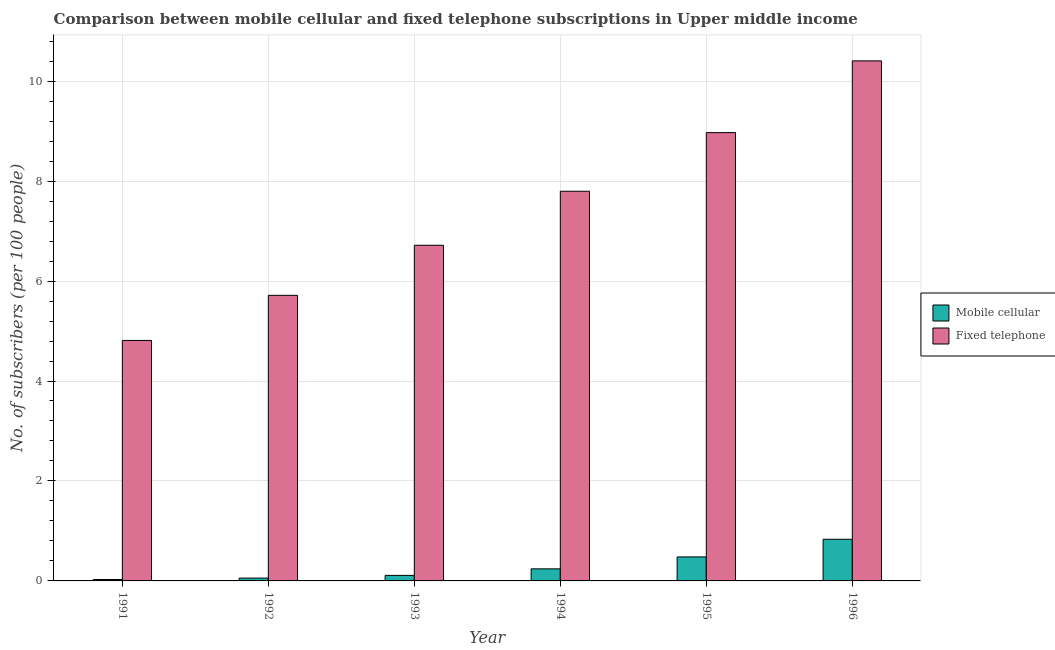How many groups of bars are there?
Your response must be concise. 6. Are the number of bars per tick equal to the number of legend labels?
Offer a terse response. Yes. How many bars are there on the 4th tick from the right?
Your answer should be compact. 2. What is the label of the 5th group of bars from the left?
Give a very brief answer. 1995. In how many cases, is the number of bars for a given year not equal to the number of legend labels?
Offer a terse response. 0. What is the number of mobile cellular subscribers in 1995?
Offer a very short reply. 0.48. Across all years, what is the maximum number of mobile cellular subscribers?
Ensure brevity in your answer.  0.83. Across all years, what is the minimum number of fixed telephone subscribers?
Provide a short and direct response. 4.81. What is the total number of fixed telephone subscribers in the graph?
Offer a terse response. 44.41. What is the difference between the number of mobile cellular subscribers in 1993 and that in 1996?
Ensure brevity in your answer.  -0.72. What is the difference between the number of mobile cellular subscribers in 1992 and the number of fixed telephone subscribers in 1995?
Offer a terse response. -0.42. What is the average number of fixed telephone subscribers per year?
Offer a very short reply. 7.4. What is the ratio of the number of fixed telephone subscribers in 1992 to that in 1993?
Make the answer very short. 0.85. Is the number of fixed telephone subscribers in 1993 less than that in 1994?
Provide a succinct answer. Yes. What is the difference between the highest and the second highest number of fixed telephone subscribers?
Your answer should be compact. 1.44. What is the difference between the highest and the lowest number of fixed telephone subscribers?
Give a very brief answer. 5.59. Is the sum of the number of fixed telephone subscribers in 1994 and 1996 greater than the maximum number of mobile cellular subscribers across all years?
Offer a terse response. Yes. What does the 1st bar from the left in 1993 represents?
Your response must be concise. Mobile cellular. What does the 2nd bar from the right in 1995 represents?
Ensure brevity in your answer.  Mobile cellular. How many bars are there?
Provide a short and direct response. 12. Are all the bars in the graph horizontal?
Provide a succinct answer. No. How many years are there in the graph?
Make the answer very short. 6. Does the graph contain grids?
Your response must be concise. Yes. What is the title of the graph?
Provide a short and direct response. Comparison between mobile cellular and fixed telephone subscriptions in Upper middle income. Does "Electricity and heat production" appear as one of the legend labels in the graph?
Keep it short and to the point. No. What is the label or title of the X-axis?
Offer a terse response. Year. What is the label or title of the Y-axis?
Keep it short and to the point. No. of subscribers (per 100 people). What is the No. of subscribers (per 100 people) in Mobile cellular in 1991?
Make the answer very short. 0.03. What is the No. of subscribers (per 100 people) of Fixed telephone in 1991?
Ensure brevity in your answer.  4.81. What is the No. of subscribers (per 100 people) of Mobile cellular in 1992?
Your answer should be very brief. 0.06. What is the No. of subscribers (per 100 people) of Fixed telephone in 1992?
Ensure brevity in your answer.  5.71. What is the No. of subscribers (per 100 people) of Mobile cellular in 1993?
Your response must be concise. 0.11. What is the No. of subscribers (per 100 people) in Fixed telephone in 1993?
Offer a terse response. 6.72. What is the No. of subscribers (per 100 people) in Mobile cellular in 1994?
Ensure brevity in your answer.  0.24. What is the No. of subscribers (per 100 people) of Fixed telephone in 1994?
Your answer should be very brief. 7.8. What is the No. of subscribers (per 100 people) of Mobile cellular in 1995?
Offer a very short reply. 0.48. What is the No. of subscribers (per 100 people) in Fixed telephone in 1995?
Offer a terse response. 8.97. What is the No. of subscribers (per 100 people) in Mobile cellular in 1996?
Offer a terse response. 0.83. What is the No. of subscribers (per 100 people) of Fixed telephone in 1996?
Your response must be concise. 10.41. Across all years, what is the maximum No. of subscribers (per 100 people) of Mobile cellular?
Offer a very short reply. 0.83. Across all years, what is the maximum No. of subscribers (per 100 people) in Fixed telephone?
Give a very brief answer. 10.41. Across all years, what is the minimum No. of subscribers (per 100 people) of Mobile cellular?
Make the answer very short. 0.03. Across all years, what is the minimum No. of subscribers (per 100 people) in Fixed telephone?
Offer a terse response. 4.81. What is the total No. of subscribers (per 100 people) of Mobile cellular in the graph?
Provide a short and direct response. 1.75. What is the total No. of subscribers (per 100 people) of Fixed telephone in the graph?
Provide a succinct answer. 44.41. What is the difference between the No. of subscribers (per 100 people) in Mobile cellular in 1991 and that in 1992?
Give a very brief answer. -0.03. What is the difference between the No. of subscribers (per 100 people) of Fixed telephone in 1991 and that in 1992?
Keep it short and to the point. -0.9. What is the difference between the No. of subscribers (per 100 people) in Mobile cellular in 1991 and that in 1993?
Provide a short and direct response. -0.08. What is the difference between the No. of subscribers (per 100 people) of Fixed telephone in 1991 and that in 1993?
Offer a terse response. -1.9. What is the difference between the No. of subscribers (per 100 people) in Mobile cellular in 1991 and that in 1994?
Make the answer very short. -0.21. What is the difference between the No. of subscribers (per 100 people) in Fixed telephone in 1991 and that in 1994?
Provide a succinct answer. -2.99. What is the difference between the No. of subscribers (per 100 people) of Mobile cellular in 1991 and that in 1995?
Ensure brevity in your answer.  -0.45. What is the difference between the No. of subscribers (per 100 people) in Fixed telephone in 1991 and that in 1995?
Provide a short and direct response. -4.16. What is the difference between the No. of subscribers (per 100 people) of Mobile cellular in 1991 and that in 1996?
Provide a succinct answer. -0.81. What is the difference between the No. of subscribers (per 100 people) of Fixed telephone in 1991 and that in 1996?
Your answer should be very brief. -5.59. What is the difference between the No. of subscribers (per 100 people) in Mobile cellular in 1992 and that in 1993?
Your response must be concise. -0.05. What is the difference between the No. of subscribers (per 100 people) of Fixed telephone in 1992 and that in 1993?
Make the answer very short. -1. What is the difference between the No. of subscribers (per 100 people) of Mobile cellular in 1992 and that in 1994?
Your answer should be very brief. -0.18. What is the difference between the No. of subscribers (per 100 people) in Fixed telephone in 1992 and that in 1994?
Provide a succinct answer. -2.08. What is the difference between the No. of subscribers (per 100 people) in Mobile cellular in 1992 and that in 1995?
Your answer should be compact. -0.42. What is the difference between the No. of subscribers (per 100 people) of Fixed telephone in 1992 and that in 1995?
Provide a succinct answer. -3.26. What is the difference between the No. of subscribers (per 100 people) in Mobile cellular in 1992 and that in 1996?
Offer a terse response. -0.78. What is the difference between the No. of subscribers (per 100 people) in Fixed telephone in 1992 and that in 1996?
Your response must be concise. -4.69. What is the difference between the No. of subscribers (per 100 people) in Mobile cellular in 1993 and that in 1994?
Give a very brief answer. -0.13. What is the difference between the No. of subscribers (per 100 people) of Fixed telephone in 1993 and that in 1994?
Provide a short and direct response. -1.08. What is the difference between the No. of subscribers (per 100 people) in Mobile cellular in 1993 and that in 1995?
Give a very brief answer. -0.37. What is the difference between the No. of subscribers (per 100 people) of Fixed telephone in 1993 and that in 1995?
Your answer should be compact. -2.25. What is the difference between the No. of subscribers (per 100 people) in Mobile cellular in 1993 and that in 1996?
Your answer should be very brief. -0.72. What is the difference between the No. of subscribers (per 100 people) in Fixed telephone in 1993 and that in 1996?
Give a very brief answer. -3.69. What is the difference between the No. of subscribers (per 100 people) of Mobile cellular in 1994 and that in 1995?
Offer a terse response. -0.24. What is the difference between the No. of subscribers (per 100 people) in Fixed telephone in 1994 and that in 1995?
Offer a terse response. -1.17. What is the difference between the No. of subscribers (per 100 people) in Mobile cellular in 1994 and that in 1996?
Provide a succinct answer. -0.59. What is the difference between the No. of subscribers (per 100 people) in Fixed telephone in 1994 and that in 1996?
Offer a terse response. -2.61. What is the difference between the No. of subscribers (per 100 people) in Mobile cellular in 1995 and that in 1996?
Provide a succinct answer. -0.35. What is the difference between the No. of subscribers (per 100 people) of Fixed telephone in 1995 and that in 1996?
Make the answer very short. -1.44. What is the difference between the No. of subscribers (per 100 people) in Mobile cellular in 1991 and the No. of subscribers (per 100 people) in Fixed telephone in 1992?
Offer a very short reply. -5.69. What is the difference between the No. of subscribers (per 100 people) of Mobile cellular in 1991 and the No. of subscribers (per 100 people) of Fixed telephone in 1993?
Your answer should be very brief. -6.69. What is the difference between the No. of subscribers (per 100 people) of Mobile cellular in 1991 and the No. of subscribers (per 100 people) of Fixed telephone in 1994?
Ensure brevity in your answer.  -7.77. What is the difference between the No. of subscribers (per 100 people) of Mobile cellular in 1991 and the No. of subscribers (per 100 people) of Fixed telephone in 1995?
Ensure brevity in your answer.  -8.94. What is the difference between the No. of subscribers (per 100 people) in Mobile cellular in 1991 and the No. of subscribers (per 100 people) in Fixed telephone in 1996?
Ensure brevity in your answer.  -10.38. What is the difference between the No. of subscribers (per 100 people) of Mobile cellular in 1992 and the No. of subscribers (per 100 people) of Fixed telephone in 1993?
Your answer should be compact. -6.66. What is the difference between the No. of subscribers (per 100 people) in Mobile cellular in 1992 and the No. of subscribers (per 100 people) in Fixed telephone in 1994?
Offer a very short reply. -7.74. What is the difference between the No. of subscribers (per 100 people) in Mobile cellular in 1992 and the No. of subscribers (per 100 people) in Fixed telephone in 1995?
Your response must be concise. -8.91. What is the difference between the No. of subscribers (per 100 people) of Mobile cellular in 1992 and the No. of subscribers (per 100 people) of Fixed telephone in 1996?
Offer a very short reply. -10.35. What is the difference between the No. of subscribers (per 100 people) of Mobile cellular in 1993 and the No. of subscribers (per 100 people) of Fixed telephone in 1994?
Offer a very short reply. -7.69. What is the difference between the No. of subscribers (per 100 people) in Mobile cellular in 1993 and the No. of subscribers (per 100 people) in Fixed telephone in 1995?
Make the answer very short. -8.86. What is the difference between the No. of subscribers (per 100 people) in Mobile cellular in 1993 and the No. of subscribers (per 100 people) in Fixed telephone in 1996?
Offer a terse response. -10.29. What is the difference between the No. of subscribers (per 100 people) in Mobile cellular in 1994 and the No. of subscribers (per 100 people) in Fixed telephone in 1995?
Ensure brevity in your answer.  -8.73. What is the difference between the No. of subscribers (per 100 people) of Mobile cellular in 1994 and the No. of subscribers (per 100 people) of Fixed telephone in 1996?
Your answer should be compact. -10.16. What is the difference between the No. of subscribers (per 100 people) in Mobile cellular in 1995 and the No. of subscribers (per 100 people) in Fixed telephone in 1996?
Make the answer very short. -9.93. What is the average No. of subscribers (per 100 people) of Mobile cellular per year?
Make the answer very short. 0.29. What is the average No. of subscribers (per 100 people) of Fixed telephone per year?
Make the answer very short. 7.4. In the year 1991, what is the difference between the No. of subscribers (per 100 people) in Mobile cellular and No. of subscribers (per 100 people) in Fixed telephone?
Offer a very short reply. -4.78. In the year 1992, what is the difference between the No. of subscribers (per 100 people) in Mobile cellular and No. of subscribers (per 100 people) in Fixed telephone?
Offer a terse response. -5.66. In the year 1993, what is the difference between the No. of subscribers (per 100 people) of Mobile cellular and No. of subscribers (per 100 people) of Fixed telephone?
Provide a succinct answer. -6.61. In the year 1994, what is the difference between the No. of subscribers (per 100 people) in Mobile cellular and No. of subscribers (per 100 people) in Fixed telephone?
Offer a very short reply. -7.56. In the year 1995, what is the difference between the No. of subscribers (per 100 people) in Mobile cellular and No. of subscribers (per 100 people) in Fixed telephone?
Keep it short and to the point. -8.49. In the year 1996, what is the difference between the No. of subscribers (per 100 people) in Mobile cellular and No. of subscribers (per 100 people) in Fixed telephone?
Ensure brevity in your answer.  -9.57. What is the ratio of the No. of subscribers (per 100 people) in Mobile cellular in 1991 to that in 1992?
Your answer should be very brief. 0.5. What is the ratio of the No. of subscribers (per 100 people) in Fixed telephone in 1991 to that in 1992?
Ensure brevity in your answer.  0.84. What is the ratio of the No. of subscribers (per 100 people) in Mobile cellular in 1991 to that in 1993?
Make the answer very short. 0.26. What is the ratio of the No. of subscribers (per 100 people) of Fixed telephone in 1991 to that in 1993?
Keep it short and to the point. 0.72. What is the ratio of the No. of subscribers (per 100 people) of Mobile cellular in 1991 to that in 1994?
Your answer should be compact. 0.12. What is the ratio of the No. of subscribers (per 100 people) of Fixed telephone in 1991 to that in 1994?
Your answer should be compact. 0.62. What is the ratio of the No. of subscribers (per 100 people) of Mobile cellular in 1991 to that in 1995?
Give a very brief answer. 0.06. What is the ratio of the No. of subscribers (per 100 people) of Fixed telephone in 1991 to that in 1995?
Keep it short and to the point. 0.54. What is the ratio of the No. of subscribers (per 100 people) of Mobile cellular in 1991 to that in 1996?
Your response must be concise. 0.03. What is the ratio of the No. of subscribers (per 100 people) in Fixed telephone in 1991 to that in 1996?
Offer a very short reply. 0.46. What is the ratio of the No. of subscribers (per 100 people) in Mobile cellular in 1992 to that in 1993?
Keep it short and to the point. 0.51. What is the ratio of the No. of subscribers (per 100 people) in Fixed telephone in 1992 to that in 1993?
Offer a very short reply. 0.85. What is the ratio of the No. of subscribers (per 100 people) in Mobile cellular in 1992 to that in 1994?
Your response must be concise. 0.24. What is the ratio of the No. of subscribers (per 100 people) of Fixed telephone in 1992 to that in 1994?
Make the answer very short. 0.73. What is the ratio of the No. of subscribers (per 100 people) of Mobile cellular in 1992 to that in 1995?
Your response must be concise. 0.12. What is the ratio of the No. of subscribers (per 100 people) of Fixed telephone in 1992 to that in 1995?
Give a very brief answer. 0.64. What is the ratio of the No. of subscribers (per 100 people) of Mobile cellular in 1992 to that in 1996?
Your answer should be compact. 0.07. What is the ratio of the No. of subscribers (per 100 people) of Fixed telephone in 1992 to that in 1996?
Offer a terse response. 0.55. What is the ratio of the No. of subscribers (per 100 people) in Mobile cellular in 1993 to that in 1994?
Your answer should be compact. 0.46. What is the ratio of the No. of subscribers (per 100 people) in Fixed telephone in 1993 to that in 1994?
Your answer should be compact. 0.86. What is the ratio of the No. of subscribers (per 100 people) in Mobile cellular in 1993 to that in 1995?
Keep it short and to the point. 0.23. What is the ratio of the No. of subscribers (per 100 people) in Fixed telephone in 1993 to that in 1995?
Provide a succinct answer. 0.75. What is the ratio of the No. of subscribers (per 100 people) of Mobile cellular in 1993 to that in 1996?
Ensure brevity in your answer.  0.13. What is the ratio of the No. of subscribers (per 100 people) of Fixed telephone in 1993 to that in 1996?
Make the answer very short. 0.65. What is the ratio of the No. of subscribers (per 100 people) in Mobile cellular in 1994 to that in 1995?
Your response must be concise. 0.5. What is the ratio of the No. of subscribers (per 100 people) of Fixed telephone in 1994 to that in 1995?
Provide a short and direct response. 0.87. What is the ratio of the No. of subscribers (per 100 people) in Mobile cellular in 1994 to that in 1996?
Your answer should be compact. 0.29. What is the ratio of the No. of subscribers (per 100 people) of Fixed telephone in 1994 to that in 1996?
Provide a succinct answer. 0.75. What is the ratio of the No. of subscribers (per 100 people) of Mobile cellular in 1995 to that in 1996?
Ensure brevity in your answer.  0.58. What is the ratio of the No. of subscribers (per 100 people) of Fixed telephone in 1995 to that in 1996?
Provide a short and direct response. 0.86. What is the difference between the highest and the second highest No. of subscribers (per 100 people) of Mobile cellular?
Keep it short and to the point. 0.35. What is the difference between the highest and the second highest No. of subscribers (per 100 people) of Fixed telephone?
Make the answer very short. 1.44. What is the difference between the highest and the lowest No. of subscribers (per 100 people) in Mobile cellular?
Keep it short and to the point. 0.81. What is the difference between the highest and the lowest No. of subscribers (per 100 people) of Fixed telephone?
Your answer should be compact. 5.59. 